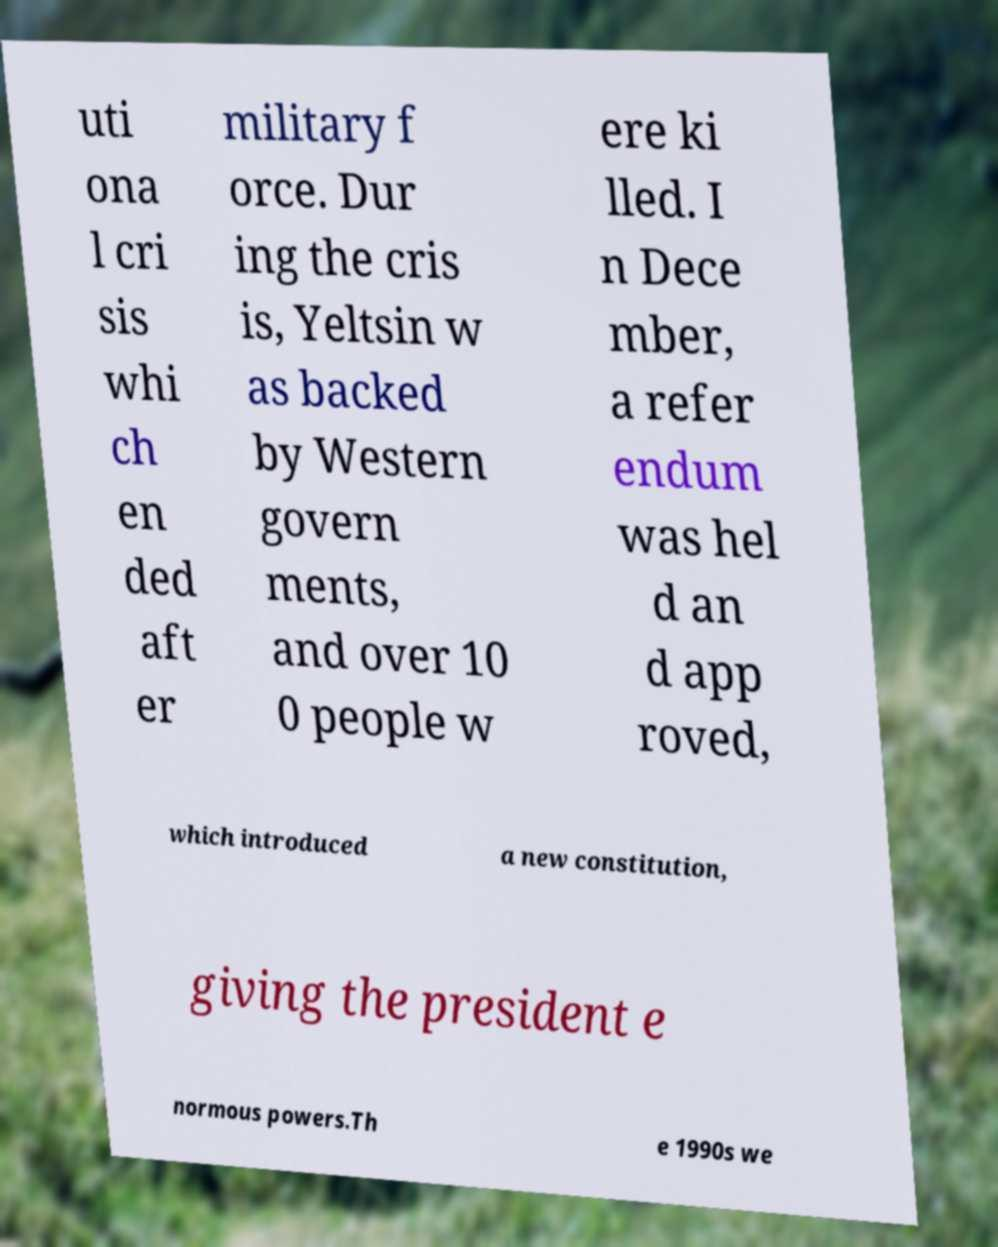Could you assist in decoding the text presented in this image and type it out clearly? uti ona l cri sis whi ch en ded aft er military f orce. Dur ing the cris is, Yeltsin w as backed by Western govern ments, and over 10 0 people w ere ki lled. I n Dece mber, a refer endum was hel d an d app roved, which introduced a new constitution, giving the president e normous powers.Th e 1990s we 